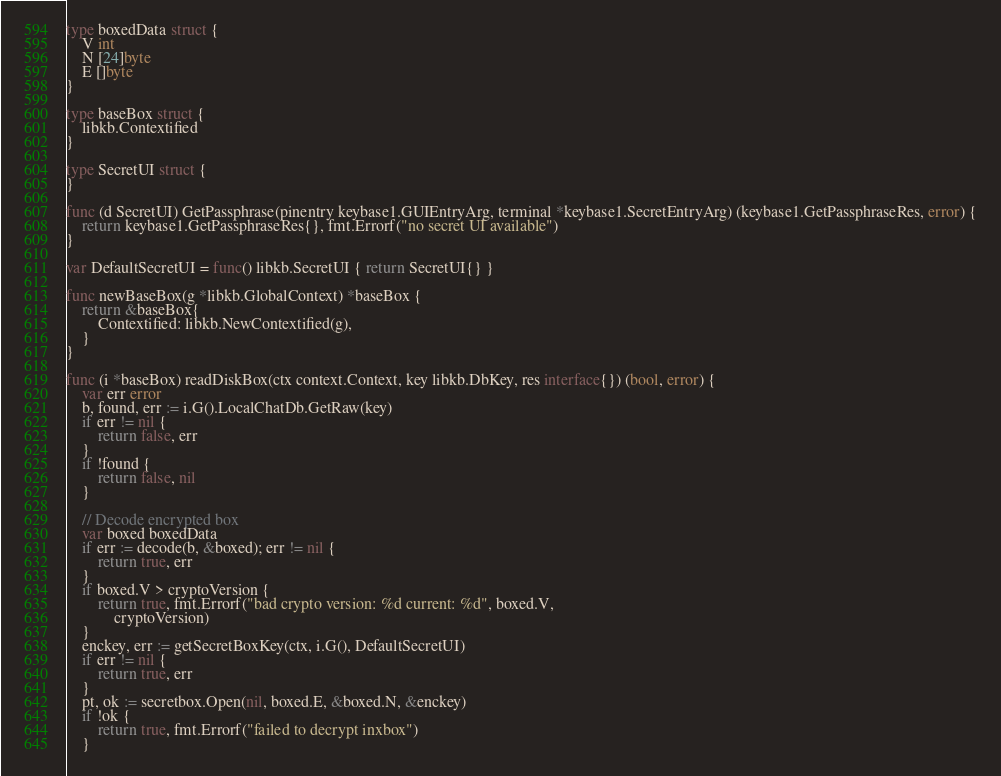<code> <loc_0><loc_0><loc_500><loc_500><_Go_>type boxedData struct {
	V int
	N [24]byte
	E []byte
}

type baseBox struct {
	libkb.Contextified
}

type SecretUI struct {
}

func (d SecretUI) GetPassphrase(pinentry keybase1.GUIEntryArg, terminal *keybase1.SecretEntryArg) (keybase1.GetPassphraseRes, error) {
	return keybase1.GetPassphraseRes{}, fmt.Errorf("no secret UI available")
}

var DefaultSecretUI = func() libkb.SecretUI { return SecretUI{} }

func newBaseBox(g *libkb.GlobalContext) *baseBox {
	return &baseBox{
		Contextified: libkb.NewContextified(g),
	}
}

func (i *baseBox) readDiskBox(ctx context.Context, key libkb.DbKey, res interface{}) (bool, error) {
	var err error
	b, found, err := i.G().LocalChatDb.GetRaw(key)
	if err != nil {
		return false, err
	}
	if !found {
		return false, nil
	}

	// Decode encrypted box
	var boxed boxedData
	if err := decode(b, &boxed); err != nil {
		return true, err
	}
	if boxed.V > cryptoVersion {
		return true, fmt.Errorf("bad crypto version: %d current: %d", boxed.V,
			cryptoVersion)
	}
	enckey, err := getSecretBoxKey(ctx, i.G(), DefaultSecretUI)
	if err != nil {
		return true, err
	}
	pt, ok := secretbox.Open(nil, boxed.E, &boxed.N, &enckey)
	if !ok {
		return true, fmt.Errorf("failed to decrypt inxbox")
	}</code> 